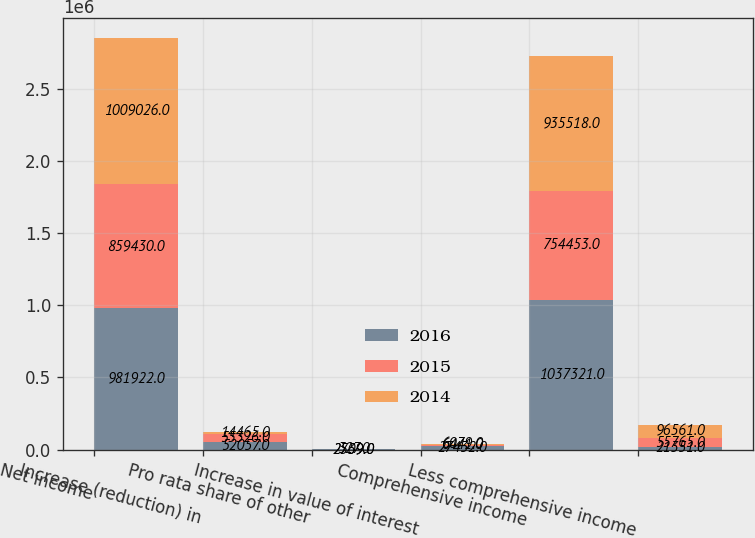Convert chart to OTSL. <chart><loc_0><loc_0><loc_500><loc_500><stacked_bar_chart><ecel><fcel>Net income<fcel>Increase (reduction) in<fcel>Pro rata share of other<fcel>Increase in value of interest<fcel>Comprehensive income<fcel>Less comprehensive income<nl><fcel>2016<fcel>981922<fcel>52057<fcel>2739<fcel>27432<fcel>1.03732e+06<fcel>21351<nl><fcel>2015<fcel>859430<fcel>55326<fcel>327<fcel>6441<fcel>754453<fcel>55765<nl><fcel>2014<fcel>1.00903e+06<fcel>14465<fcel>2509<fcel>6079<fcel>935518<fcel>96561<nl></chart> 